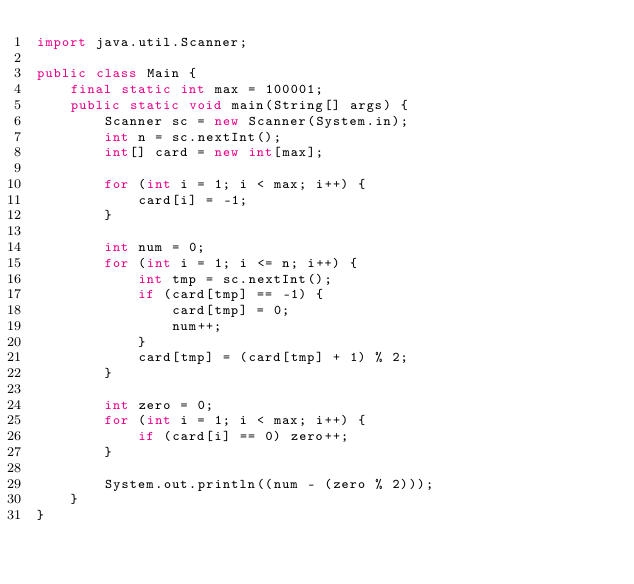Convert code to text. <code><loc_0><loc_0><loc_500><loc_500><_Java_>import java.util.Scanner;

public class Main {
    final static int max = 100001;
    public static void main(String[] args) {
        Scanner sc = new Scanner(System.in);
        int n = sc.nextInt();
        int[] card = new int[max];

        for (int i = 1; i < max; i++) {
            card[i] = -1;
        }

        int num = 0;
        for (int i = 1; i <= n; i++) {
            int tmp = sc.nextInt();
            if (card[tmp] == -1) {
                card[tmp] = 0;
                num++;
            }
            card[tmp] = (card[tmp] + 1) % 2;
        }

        int zero = 0;
        for (int i = 1; i < max; i++) {
            if (card[i] == 0) zero++;
        }

        System.out.println((num - (zero % 2)));
    }
}
</code> 